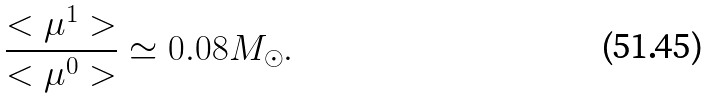Convert formula to latex. <formula><loc_0><loc_0><loc_500><loc_500>\frac { < \mu ^ { 1 } > } { < \mu ^ { 0 } > } \simeq 0 . 0 8 M _ { \odot } .</formula> 